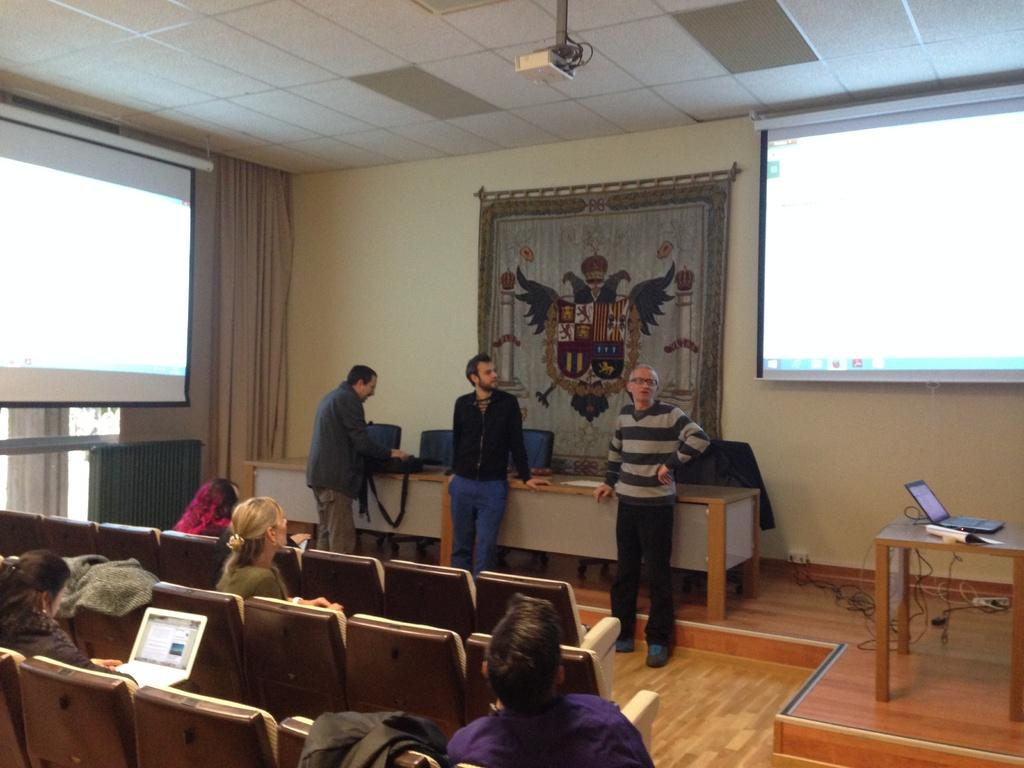What are the people in the image doing? There are people sitting and standing in the image. What can be seen in the background of the image? There is a wall, a curtain, two screens, a cloth, the ceiling, and a projector in the background of the image. What type of quill is being used to write on the cloth in the image? There is no quill or writing on the cloth present in the image. What is the weather like outside the room in the image? The image does not show the outside of the room, so it is not possible to determine the weather. 